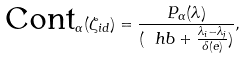Convert formula to latex. <formula><loc_0><loc_0><loc_500><loc_500>\text {Cont} _ { \Gamma } ( \zeta _ { i d } ) = \frac { P _ { \Gamma } ( \lambda ) } { ( \ h b + \frac { \lambda _ { i } - \lambda _ { j } } { \delta ( e ) } ) } ,</formula> 